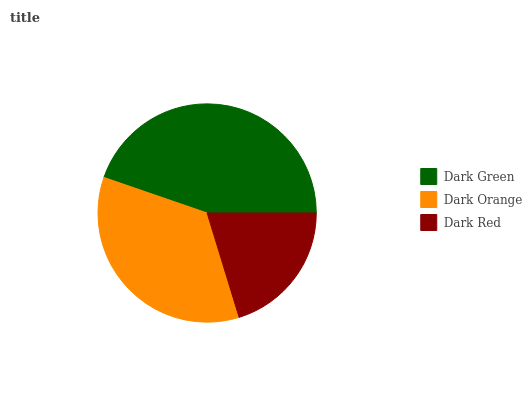Is Dark Red the minimum?
Answer yes or no. Yes. Is Dark Green the maximum?
Answer yes or no. Yes. Is Dark Orange the minimum?
Answer yes or no. No. Is Dark Orange the maximum?
Answer yes or no. No. Is Dark Green greater than Dark Orange?
Answer yes or no. Yes. Is Dark Orange less than Dark Green?
Answer yes or no. Yes. Is Dark Orange greater than Dark Green?
Answer yes or no. No. Is Dark Green less than Dark Orange?
Answer yes or no. No. Is Dark Orange the high median?
Answer yes or no. Yes. Is Dark Orange the low median?
Answer yes or no. Yes. Is Dark Green the high median?
Answer yes or no. No. Is Dark Red the low median?
Answer yes or no. No. 